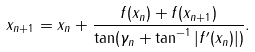<formula> <loc_0><loc_0><loc_500><loc_500>x _ { n + 1 } = x _ { n } + \frac { f ( x _ { n } ) + f ( x _ { n + 1 } ) } { \tan ( \gamma _ { n } + \tan ^ { - 1 } | f ^ { \prime } ( x _ { n } ) | ) } .</formula> 